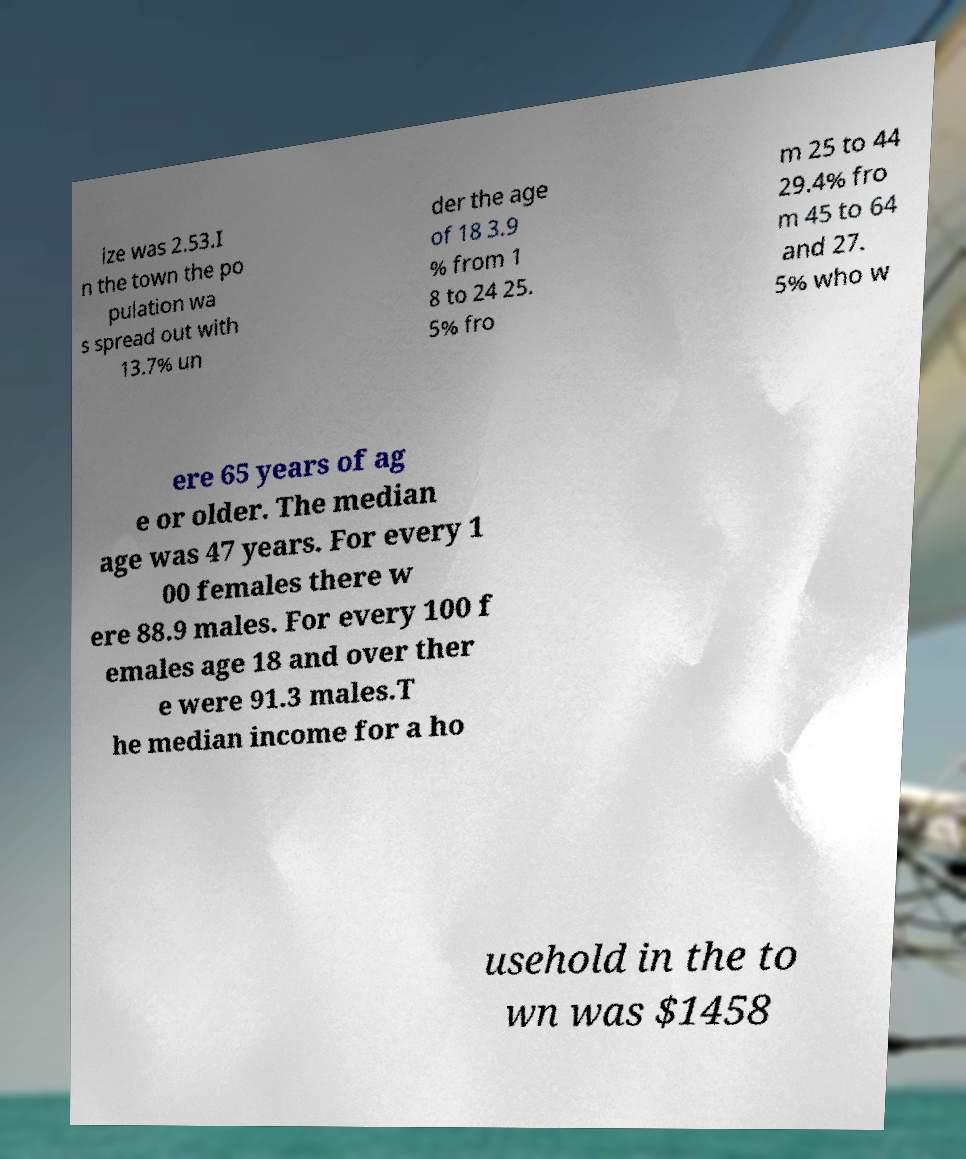Please read and relay the text visible in this image. What does it say? ize was 2.53.I n the town the po pulation wa s spread out with 13.7% un der the age of 18 3.9 % from 1 8 to 24 25. 5% fro m 25 to 44 29.4% fro m 45 to 64 and 27. 5% who w ere 65 years of ag e or older. The median age was 47 years. For every 1 00 females there w ere 88.9 males. For every 100 f emales age 18 and over ther e were 91.3 males.T he median income for a ho usehold in the to wn was $1458 